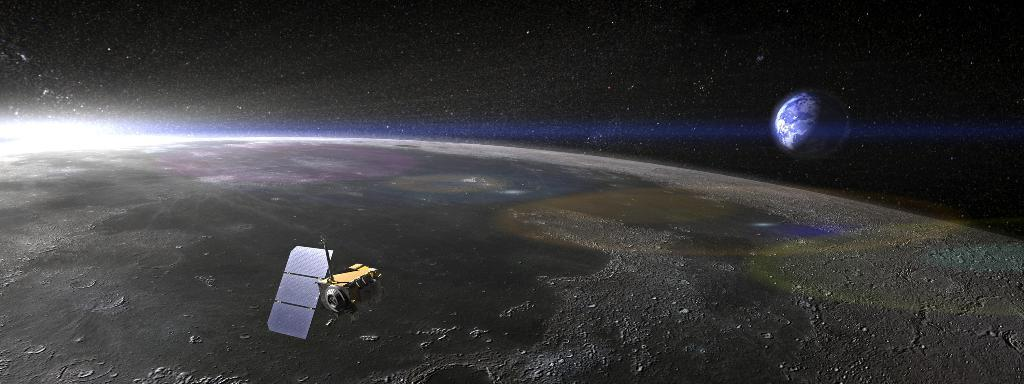What celestial bodies are present in the image? The image contains the Earth and the Moon. What else can be seen in the image besides the Earth and the Moon? There is a satellite in the image. What is the color of the background in the image? The background of the image is dark. What type of paint is used to create the tiger's stripes in the image? There is no tiger present in the image, so there are no stripes to be painted. 